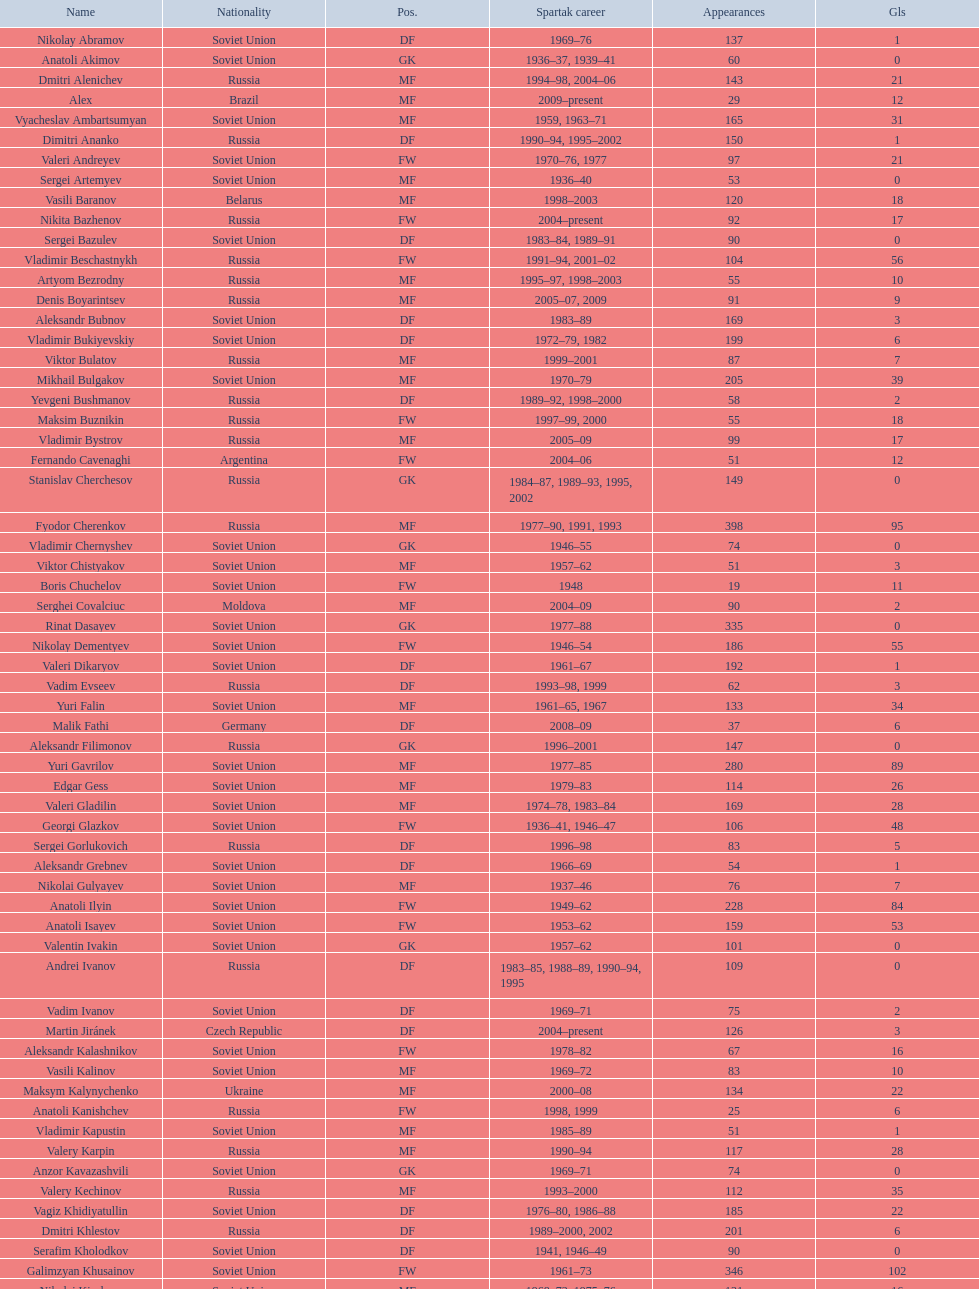Which player has the most appearances with the club? Fyodor Cherenkov. 